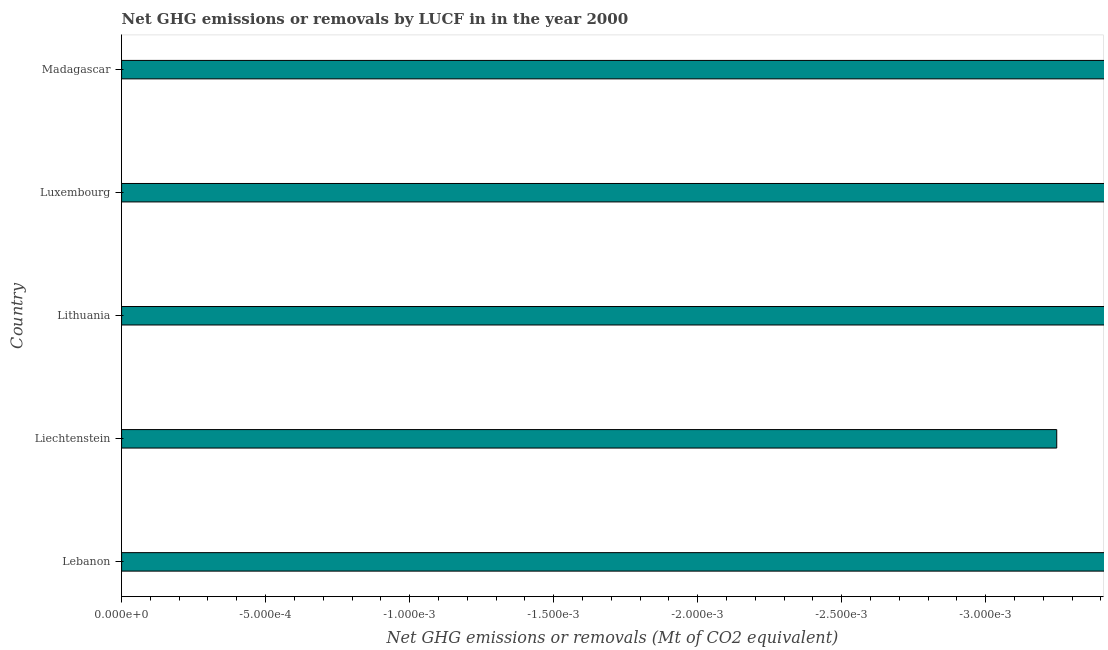Does the graph contain grids?
Ensure brevity in your answer.  No. What is the title of the graph?
Your response must be concise. Net GHG emissions or removals by LUCF in in the year 2000. What is the label or title of the X-axis?
Make the answer very short. Net GHG emissions or removals (Mt of CO2 equivalent). What is the label or title of the Y-axis?
Your response must be concise. Country. Across all countries, what is the minimum ghg net emissions or removals?
Keep it short and to the point. 0. In how many countries, is the ghg net emissions or removals greater than the average ghg net emissions or removals taken over all countries?
Make the answer very short. 0. Are all the bars in the graph horizontal?
Keep it short and to the point. Yes. What is the Net GHG emissions or removals (Mt of CO2 equivalent) of Lebanon?
Keep it short and to the point. 0. 